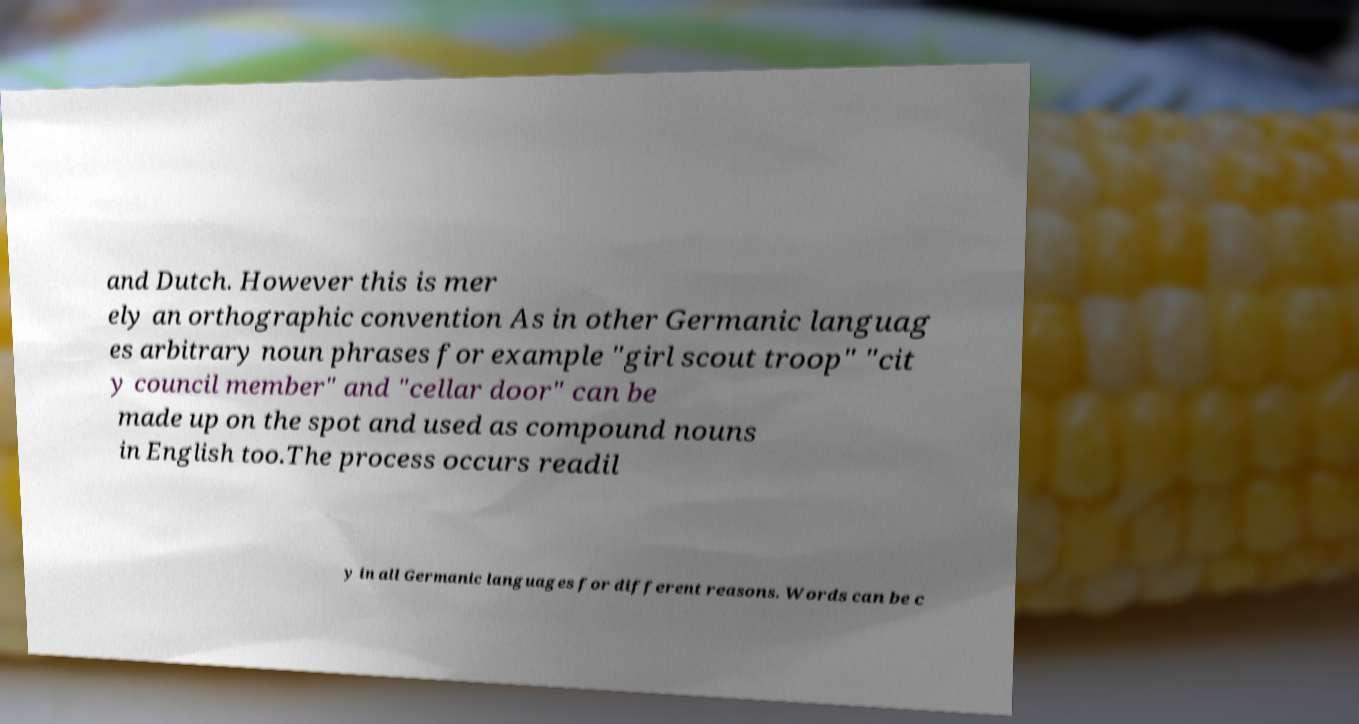Can you accurately transcribe the text from the provided image for me? and Dutch. However this is mer ely an orthographic convention As in other Germanic languag es arbitrary noun phrases for example "girl scout troop" "cit y council member" and "cellar door" can be made up on the spot and used as compound nouns in English too.The process occurs readil y in all Germanic languages for different reasons. Words can be c 